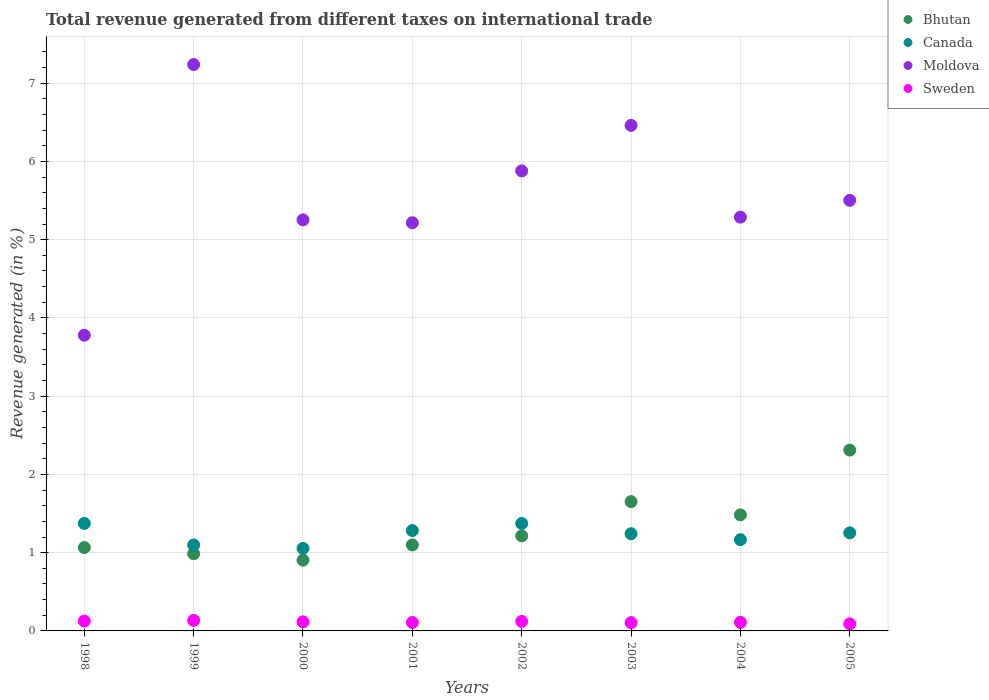How many different coloured dotlines are there?
Ensure brevity in your answer.  4. Is the number of dotlines equal to the number of legend labels?
Offer a terse response. Yes. What is the total revenue generated in Bhutan in 2002?
Your response must be concise. 1.21. Across all years, what is the maximum total revenue generated in Sweden?
Provide a short and direct response. 0.13. Across all years, what is the minimum total revenue generated in Canada?
Keep it short and to the point. 1.05. In which year was the total revenue generated in Moldova maximum?
Make the answer very short. 1999. What is the total total revenue generated in Bhutan in the graph?
Ensure brevity in your answer.  10.72. What is the difference between the total revenue generated in Moldova in 1998 and that in 2002?
Ensure brevity in your answer.  -2.1. What is the difference between the total revenue generated in Moldova in 1998 and the total revenue generated in Canada in 2004?
Ensure brevity in your answer.  2.61. What is the average total revenue generated in Bhutan per year?
Your answer should be very brief. 1.34. In the year 2002, what is the difference between the total revenue generated in Canada and total revenue generated in Sweden?
Offer a terse response. 1.25. In how many years, is the total revenue generated in Moldova greater than 6.8 %?
Your answer should be compact. 1. What is the ratio of the total revenue generated in Sweden in 1998 to that in 2002?
Provide a succinct answer. 1.03. Is the total revenue generated in Sweden in 1998 less than that in 2003?
Make the answer very short. No. What is the difference between the highest and the second highest total revenue generated in Canada?
Your answer should be very brief. 0. What is the difference between the highest and the lowest total revenue generated in Sweden?
Make the answer very short. 0.04. Is the sum of the total revenue generated in Sweden in 1999 and 2003 greater than the maximum total revenue generated in Bhutan across all years?
Offer a terse response. No. Is it the case that in every year, the sum of the total revenue generated in Bhutan and total revenue generated in Moldova  is greater than the total revenue generated in Canada?
Make the answer very short. Yes. Is the total revenue generated in Moldova strictly greater than the total revenue generated in Sweden over the years?
Your answer should be very brief. Yes. Is the total revenue generated in Bhutan strictly less than the total revenue generated in Sweden over the years?
Your response must be concise. No. How many dotlines are there?
Keep it short and to the point. 4. What is the difference between two consecutive major ticks on the Y-axis?
Provide a succinct answer. 1. Does the graph contain any zero values?
Give a very brief answer. No. What is the title of the graph?
Your answer should be compact. Total revenue generated from different taxes on international trade. Does "High income" appear as one of the legend labels in the graph?
Offer a very short reply. No. What is the label or title of the Y-axis?
Make the answer very short. Revenue generated (in %). What is the Revenue generated (in %) of Bhutan in 1998?
Give a very brief answer. 1.07. What is the Revenue generated (in %) of Canada in 1998?
Ensure brevity in your answer.  1.37. What is the Revenue generated (in %) of Moldova in 1998?
Ensure brevity in your answer.  3.78. What is the Revenue generated (in %) in Sweden in 1998?
Offer a terse response. 0.13. What is the Revenue generated (in %) of Bhutan in 1999?
Provide a succinct answer. 0.99. What is the Revenue generated (in %) in Canada in 1999?
Offer a very short reply. 1.1. What is the Revenue generated (in %) in Moldova in 1999?
Offer a terse response. 7.24. What is the Revenue generated (in %) in Sweden in 1999?
Offer a terse response. 0.13. What is the Revenue generated (in %) of Bhutan in 2000?
Your answer should be compact. 0.91. What is the Revenue generated (in %) of Canada in 2000?
Your response must be concise. 1.05. What is the Revenue generated (in %) of Moldova in 2000?
Provide a succinct answer. 5.25. What is the Revenue generated (in %) of Sweden in 2000?
Provide a short and direct response. 0.12. What is the Revenue generated (in %) in Bhutan in 2001?
Keep it short and to the point. 1.1. What is the Revenue generated (in %) of Canada in 2001?
Provide a succinct answer. 1.28. What is the Revenue generated (in %) in Moldova in 2001?
Provide a succinct answer. 5.22. What is the Revenue generated (in %) of Sweden in 2001?
Provide a succinct answer. 0.11. What is the Revenue generated (in %) in Bhutan in 2002?
Keep it short and to the point. 1.21. What is the Revenue generated (in %) of Canada in 2002?
Provide a short and direct response. 1.37. What is the Revenue generated (in %) in Moldova in 2002?
Your response must be concise. 5.88. What is the Revenue generated (in %) in Sweden in 2002?
Ensure brevity in your answer.  0.12. What is the Revenue generated (in %) of Bhutan in 2003?
Your answer should be very brief. 1.65. What is the Revenue generated (in %) of Canada in 2003?
Your response must be concise. 1.24. What is the Revenue generated (in %) of Moldova in 2003?
Your response must be concise. 6.46. What is the Revenue generated (in %) of Sweden in 2003?
Keep it short and to the point. 0.11. What is the Revenue generated (in %) in Bhutan in 2004?
Your response must be concise. 1.48. What is the Revenue generated (in %) of Canada in 2004?
Your answer should be very brief. 1.17. What is the Revenue generated (in %) in Moldova in 2004?
Your answer should be compact. 5.29. What is the Revenue generated (in %) in Sweden in 2004?
Make the answer very short. 0.11. What is the Revenue generated (in %) of Bhutan in 2005?
Provide a succinct answer. 2.31. What is the Revenue generated (in %) of Canada in 2005?
Offer a terse response. 1.25. What is the Revenue generated (in %) in Moldova in 2005?
Keep it short and to the point. 5.5. What is the Revenue generated (in %) in Sweden in 2005?
Make the answer very short. 0.09. Across all years, what is the maximum Revenue generated (in %) in Bhutan?
Make the answer very short. 2.31. Across all years, what is the maximum Revenue generated (in %) of Canada?
Your answer should be compact. 1.37. Across all years, what is the maximum Revenue generated (in %) in Moldova?
Make the answer very short. 7.24. Across all years, what is the maximum Revenue generated (in %) of Sweden?
Ensure brevity in your answer.  0.13. Across all years, what is the minimum Revenue generated (in %) of Bhutan?
Provide a short and direct response. 0.91. Across all years, what is the minimum Revenue generated (in %) in Canada?
Provide a short and direct response. 1.05. Across all years, what is the minimum Revenue generated (in %) of Moldova?
Give a very brief answer. 3.78. Across all years, what is the minimum Revenue generated (in %) of Sweden?
Your response must be concise. 0.09. What is the total Revenue generated (in %) of Bhutan in the graph?
Ensure brevity in your answer.  10.72. What is the total Revenue generated (in %) of Canada in the graph?
Your response must be concise. 9.84. What is the total Revenue generated (in %) in Moldova in the graph?
Your response must be concise. 44.62. What is the total Revenue generated (in %) in Sweden in the graph?
Provide a succinct answer. 0.91. What is the difference between the Revenue generated (in %) of Bhutan in 1998 and that in 1999?
Offer a terse response. 0.08. What is the difference between the Revenue generated (in %) of Canada in 1998 and that in 1999?
Your answer should be compact. 0.28. What is the difference between the Revenue generated (in %) of Moldova in 1998 and that in 1999?
Give a very brief answer. -3.46. What is the difference between the Revenue generated (in %) in Sweden in 1998 and that in 1999?
Your answer should be very brief. -0.01. What is the difference between the Revenue generated (in %) in Bhutan in 1998 and that in 2000?
Ensure brevity in your answer.  0.16. What is the difference between the Revenue generated (in %) in Canada in 1998 and that in 2000?
Provide a short and direct response. 0.32. What is the difference between the Revenue generated (in %) in Moldova in 1998 and that in 2000?
Provide a succinct answer. -1.47. What is the difference between the Revenue generated (in %) of Sweden in 1998 and that in 2000?
Make the answer very short. 0.01. What is the difference between the Revenue generated (in %) of Bhutan in 1998 and that in 2001?
Your answer should be compact. -0.03. What is the difference between the Revenue generated (in %) of Canada in 1998 and that in 2001?
Offer a terse response. 0.09. What is the difference between the Revenue generated (in %) in Moldova in 1998 and that in 2001?
Provide a short and direct response. -1.44. What is the difference between the Revenue generated (in %) of Sweden in 1998 and that in 2001?
Your answer should be very brief. 0.02. What is the difference between the Revenue generated (in %) in Bhutan in 1998 and that in 2002?
Your response must be concise. -0.15. What is the difference between the Revenue generated (in %) in Canada in 1998 and that in 2002?
Your response must be concise. 0. What is the difference between the Revenue generated (in %) in Moldova in 1998 and that in 2002?
Ensure brevity in your answer.  -2.1. What is the difference between the Revenue generated (in %) in Sweden in 1998 and that in 2002?
Ensure brevity in your answer.  0. What is the difference between the Revenue generated (in %) of Bhutan in 1998 and that in 2003?
Ensure brevity in your answer.  -0.59. What is the difference between the Revenue generated (in %) of Canada in 1998 and that in 2003?
Your answer should be very brief. 0.13. What is the difference between the Revenue generated (in %) in Moldova in 1998 and that in 2003?
Your answer should be compact. -2.68. What is the difference between the Revenue generated (in %) in Sweden in 1998 and that in 2003?
Ensure brevity in your answer.  0.02. What is the difference between the Revenue generated (in %) of Bhutan in 1998 and that in 2004?
Make the answer very short. -0.42. What is the difference between the Revenue generated (in %) in Canada in 1998 and that in 2004?
Keep it short and to the point. 0.21. What is the difference between the Revenue generated (in %) in Moldova in 1998 and that in 2004?
Provide a succinct answer. -1.51. What is the difference between the Revenue generated (in %) in Sweden in 1998 and that in 2004?
Offer a very short reply. 0.02. What is the difference between the Revenue generated (in %) in Bhutan in 1998 and that in 2005?
Provide a short and direct response. -1.25. What is the difference between the Revenue generated (in %) in Canada in 1998 and that in 2005?
Make the answer very short. 0.12. What is the difference between the Revenue generated (in %) of Moldova in 1998 and that in 2005?
Offer a terse response. -1.72. What is the difference between the Revenue generated (in %) of Sweden in 1998 and that in 2005?
Your response must be concise. 0.04. What is the difference between the Revenue generated (in %) of Bhutan in 1999 and that in 2000?
Offer a terse response. 0.08. What is the difference between the Revenue generated (in %) of Canada in 1999 and that in 2000?
Give a very brief answer. 0.04. What is the difference between the Revenue generated (in %) in Moldova in 1999 and that in 2000?
Offer a terse response. 1.98. What is the difference between the Revenue generated (in %) in Sweden in 1999 and that in 2000?
Offer a terse response. 0.02. What is the difference between the Revenue generated (in %) in Bhutan in 1999 and that in 2001?
Provide a succinct answer. -0.11. What is the difference between the Revenue generated (in %) in Canada in 1999 and that in 2001?
Your response must be concise. -0.18. What is the difference between the Revenue generated (in %) in Moldova in 1999 and that in 2001?
Give a very brief answer. 2.02. What is the difference between the Revenue generated (in %) in Sweden in 1999 and that in 2001?
Ensure brevity in your answer.  0.03. What is the difference between the Revenue generated (in %) in Bhutan in 1999 and that in 2002?
Keep it short and to the point. -0.23. What is the difference between the Revenue generated (in %) of Canada in 1999 and that in 2002?
Your answer should be compact. -0.27. What is the difference between the Revenue generated (in %) in Moldova in 1999 and that in 2002?
Offer a very short reply. 1.36. What is the difference between the Revenue generated (in %) of Sweden in 1999 and that in 2002?
Offer a terse response. 0.01. What is the difference between the Revenue generated (in %) of Bhutan in 1999 and that in 2003?
Offer a very short reply. -0.67. What is the difference between the Revenue generated (in %) of Canada in 1999 and that in 2003?
Make the answer very short. -0.14. What is the difference between the Revenue generated (in %) of Moldova in 1999 and that in 2003?
Your answer should be very brief. 0.78. What is the difference between the Revenue generated (in %) in Sweden in 1999 and that in 2003?
Offer a very short reply. 0.03. What is the difference between the Revenue generated (in %) of Bhutan in 1999 and that in 2004?
Offer a terse response. -0.5. What is the difference between the Revenue generated (in %) in Canada in 1999 and that in 2004?
Give a very brief answer. -0.07. What is the difference between the Revenue generated (in %) of Moldova in 1999 and that in 2004?
Your response must be concise. 1.95. What is the difference between the Revenue generated (in %) in Sweden in 1999 and that in 2004?
Your answer should be very brief. 0.02. What is the difference between the Revenue generated (in %) of Bhutan in 1999 and that in 2005?
Your response must be concise. -1.32. What is the difference between the Revenue generated (in %) of Canada in 1999 and that in 2005?
Provide a succinct answer. -0.15. What is the difference between the Revenue generated (in %) of Moldova in 1999 and that in 2005?
Your answer should be compact. 1.74. What is the difference between the Revenue generated (in %) of Sweden in 1999 and that in 2005?
Your response must be concise. 0.04. What is the difference between the Revenue generated (in %) in Bhutan in 2000 and that in 2001?
Your answer should be compact. -0.19. What is the difference between the Revenue generated (in %) in Canada in 2000 and that in 2001?
Your response must be concise. -0.23. What is the difference between the Revenue generated (in %) of Moldova in 2000 and that in 2001?
Your answer should be compact. 0.04. What is the difference between the Revenue generated (in %) in Sweden in 2000 and that in 2001?
Offer a very short reply. 0.01. What is the difference between the Revenue generated (in %) in Bhutan in 2000 and that in 2002?
Make the answer very short. -0.31. What is the difference between the Revenue generated (in %) in Canada in 2000 and that in 2002?
Provide a succinct answer. -0.32. What is the difference between the Revenue generated (in %) in Moldova in 2000 and that in 2002?
Your answer should be very brief. -0.63. What is the difference between the Revenue generated (in %) in Sweden in 2000 and that in 2002?
Ensure brevity in your answer.  -0.01. What is the difference between the Revenue generated (in %) of Bhutan in 2000 and that in 2003?
Give a very brief answer. -0.75. What is the difference between the Revenue generated (in %) in Canada in 2000 and that in 2003?
Make the answer very short. -0.19. What is the difference between the Revenue generated (in %) of Moldova in 2000 and that in 2003?
Provide a short and direct response. -1.21. What is the difference between the Revenue generated (in %) of Sweden in 2000 and that in 2003?
Make the answer very short. 0.01. What is the difference between the Revenue generated (in %) in Bhutan in 2000 and that in 2004?
Provide a short and direct response. -0.58. What is the difference between the Revenue generated (in %) in Canada in 2000 and that in 2004?
Ensure brevity in your answer.  -0.11. What is the difference between the Revenue generated (in %) in Moldova in 2000 and that in 2004?
Your answer should be very brief. -0.03. What is the difference between the Revenue generated (in %) of Sweden in 2000 and that in 2004?
Provide a succinct answer. 0.01. What is the difference between the Revenue generated (in %) of Bhutan in 2000 and that in 2005?
Provide a short and direct response. -1.41. What is the difference between the Revenue generated (in %) of Canada in 2000 and that in 2005?
Make the answer very short. -0.2. What is the difference between the Revenue generated (in %) of Moldova in 2000 and that in 2005?
Your answer should be compact. -0.25. What is the difference between the Revenue generated (in %) in Sweden in 2000 and that in 2005?
Keep it short and to the point. 0.03. What is the difference between the Revenue generated (in %) in Bhutan in 2001 and that in 2002?
Provide a succinct answer. -0.12. What is the difference between the Revenue generated (in %) in Canada in 2001 and that in 2002?
Your answer should be very brief. -0.09. What is the difference between the Revenue generated (in %) of Moldova in 2001 and that in 2002?
Your response must be concise. -0.66. What is the difference between the Revenue generated (in %) of Sweden in 2001 and that in 2002?
Ensure brevity in your answer.  -0.01. What is the difference between the Revenue generated (in %) of Bhutan in 2001 and that in 2003?
Keep it short and to the point. -0.55. What is the difference between the Revenue generated (in %) in Canada in 2001 and that in 2003?
Your answer should be compact. 0.04. What is the difference between the Revenue generated (in %) of Moldova in 2001 and that in 2003?
Your answer should be very brief. -1.24. What is the difference between the Revenue generated (in %) of Sweden in 2001 and that in 2003?
Keep it short and to the point. 0. What is the difference between the Revenue generated (in %) in Bhutan in 2001 and that in 2004?
Your answer should be compact. -0.38. What is the difference between the Revenue generated (in %) of Canada in 2001 and that in 2004?
Offer a very short reply. 0.12. What is the difference between the Revenue generated (in %) in Moldova in 2001 and that in 2004?
Your answer should be compact. -0.07. What is the difference between the Revenue generated (in %) of Sweden in 2001 and that in 2004?
Provide a short and direct response. -0. What is the difference between the Revenue generated (in %) of Bhutan in 2001 and that in 2005?
Provide a succinct answer. -1.21. What is the difference between the Revenue generated (in %) of Canada in 2001 and that in 2005?
Offer a terse response. 0.03. What is the difference between the Revenue generated (in %) in Moldova in 2001 and that in 2005?
Ensure brevity in your answer.  -0.29. What is the difference between the Revenue generated (in %) in Sweden in 2001 and that in 2005?
Make the answer very short. 0.02. What is the difference between the Revenue generated (in %) in Bhutan in 2002 and that in 2003?
Give a very brief answer. -0.44. What is the difference between the Revenue generated (in %) in Canada in 2002 and that in 2003?
Your response must be concise. 0.13. What is the difference between the Revenue generated (in %) in Moldova in 2002 and that in 2003?
Keep it short and to the point. -0.58. What is the difference between the Revenue generated (in %) in Sweden in 2002 and that in 2003?
Keep it short and to the point. 0.02. What is the difference between the Revenue generated (in %) of Bhutan in 2002 and that in 2004?
Your answer should be very brief. -0.27. What is the difference between the Revenue generated (in %) in Canada in 2002 and that in 2004?
Your answer should be very brief. 0.21. What is the difference between the Revenue generated (in %) in Moldova in 2002 and that in 2004?
Your response must be concise. 0.59. What is the difference between the Revenue generated (in %) in Sweden in 2002 and that in 2004?
Give a very brief answer. 0.01. What is the difference between the Revenue generated (in %) of Bhutan in 2002 and that in 2005?
Provide a short and direct response. -1.1. What is the difference between the Revenue generated (in %) of Canada in 2002 and that in 2005?
Keep it short and to the point. 0.12. What is the difference between the Revenue generated (in %) of Moldova in 2002 and that in 2005?
Your answer should be compact. 0.38. What is the difference between the Revenue generated (in %) in Sweden in 2002 and that in 2005?
Ensure brevity in your answer.  0.03. What is the difference between the Revenue generated (in %) in Bhutan in 2003 and that in 2004?
Provide a succinct answer. 0.17. What is the difference between the Revenue generated (in %) in Canada in 2003 and that in 2004?
Your response must be concise. 0.08. What is the difference between the Revenue generated (in %) in Moldova in 2003 and that in 2004?
Ensure brevity in your answer.  1.17. What is the difference between the Revenue generated (in %) in Sweden in 2003 and that in 2004?
Give a very brief answer. -0. What is the difference between the Revenue generated (in %) in Bhutan in 2003 and that in 2005?
Offer a very short reply. -0.66. What is the difference between the Revenue generated (in %) of Canada in 2003 and that in 2005?
Your answer should be very brief. -0.01. What is the difference between the Revenue generated (in %) in Moldova in 2003 and that in 2005?
Give a very brief answer. 0.96. What is the difference between the Revenue generated (in %) of Sweden in 2003 and that in 2005?
Offer a terse response. 0.02. What is the difference between the Revenue generated (in %) in Bhutan in 2004 and that in 2005?
Offer a very short reply. -0.83. What is the difference between the Revenue generated (in %) of Canada in 2004 and that in 2005?
Offer a terse response. -0.09. What is the difference between the Revenue generated (in %) in Moldova in 2004 and that in 2005?
Offer a very short reply. -0.21. What is the difference between the Revenue generated (in %) in Sweden in 2004 and that in 2005?
Keep it short and to the point. 0.02. What is the difference between the Revenue generated (in %) in Bhutan in 1998 and the Revenue generated (in %) in Canada in 1999?
Your answer should be very brief. -0.03. What is the difference between the Revenue generated (in %) in Bhutan in 1998 and the Revenue generated (in %) in Moldova in 1999?
Provide a short and direct response. -6.17. What is the difference between the Revenue generated (in %) in Canada in 1998 and the Revenue generated (in %) in Moldova in 1999?
Ensure brevity in your answer.  -5.86. What is the difference between the Revenue generated (in %) of Canada in 1998 and the Revenue generated (in %) of Sweden in 1999?
Offer a terse response. 1.24. What is the difference between the Revenue generated (in %) of Moldova in 1998 and the Revenue generated (in %) of Sweden in 1999?
Make the answer very short. 3.64. What is the difference between the Revenue generated (in %) in Bhutan in 1998 and the Revenue generated (in %) in Canada in 2000?
Your response must be concise. 0.01. What is the difference between the Revenue generated (in %) in Bhutan in 1998 and the Revenue generated (in %) in Moldova in 2000?
Give a very brief answer. -4.19. What is the difference between the Revenue generated (in %) of Bhutan in 1998 and the Revenue generated (in %) of Sweden in 2000?
Give a very brief answer. 0.95. What is the difference between the Revenue generated (in %) in Canada in 1998 and the Revenue generated (in %) in Moldova in 2000?
Give a very brief answer. -3.88. What is the difference between the Revenue generated (in %) in Canada in 1998 and the Revenue generated (in %) in Sweden in 2000?
Provide a short and direct response. 1.26. What is the difference between the Revenue generated (in %) of Moldova in 1998 and the Revenue generated (in %) of Sweden in 2000?
Provide a succinct answer. 3.66. What is the difference between the Revenue generated (in %) in Bhutan in 1998 and the Revenue generated (in %) in Canada in 2001?
Give a very brief answer. -0.22. What is the difference between the Revenue generated (in %) in Bhutan in 1998 and the Revenue generated (in %) in Moldova in 2001?
Provide a succinct answer. -4.15. What is the difference between the Revenue generated (in %) in Bhutan in 1998 and the Revenue generated (in %) in Sweden in 2001?
Offer a very short reply. 0.96. What is the difference between the Revenue generated (in %) of Canada in 1998 and the Revenue generated (in %) of Moldova in 2001?
Offer a terse response. -3.84. What is the difference between the Revenue generated (in %) of Canada in 1998 and the Revenue generated (in %) of Sweden in 2001?
Give a very brief answer. 1.27. What is the difference between the Revenue generated (in %) in Moldova in 1998 and the Revenue generated (in %) in Sweden in 2001?
Provide a short and direct response. 3.67. What is the difference between the Revenue generated (in %) in Bhutan in 1998 and the Revenue generated (in %) in Canada in 2002?
Your response must be concise. -0.31. What is the difference between the Revenue generated (in %) in Bhutan in 1998 and the Revenue generated (in %) in Moldova in 2002?
Provide a short and direct response. -4.81. What is the difference between the Revenue generated (in %) of Bhutan in 1998 and the Revenue generated (in %) of Sweden in 2002?
Ensure brevity in your answer.  0.94. What is the difference between the Revenue generated (in %) in Canada in 1998 and the Revenue generated (in %) in Moldova in 2002?
Make the answer very short. -4.5. What is the difference between the Revenue generated (in %) in Canada in 1998 and the Revenue generated (in %) in Sweden in 2002?
Offer a very short reply. 1.25. What is the difference between the Revenue generated (in %) in Moldova in 1998 and the Revenue generated (in %) in Sweden in 2002?
Offer a terse response. 3.66. What is the difference between the Revenue generated (in %) of Bhutan in 1998 and the Revenue generated (in %) of Canada in 2003?
Ensure brevity in your answer.  -0.18. What is the difference between the Revenue generated (in %) of Bhutan in 1998 and the Revenue generated (in %) of Moldova in 2003?
Your answer should be very brief. -5.4. What is the difference between the Revenue generated (in %) of Bhutan in 1998 and the Revenue generated (in %) of Sweden in 2003?
Your answer should be very brief. 0.96. What is the difference between the Revenue generated (in %) in Canada in 1998 and the Revenue generated (in %) in Moldova in 2003?
Give a very brief answer. -5.09. What is the difference between the Revenue generated (in %) of Canada in 1998 and the Revenue generated (in %) of Sweden in 2003?
Your answer should be very brief. 1.27. What is the difference between the Revenue generated (in %) in Moldova in 1998 and the Revenue generated (in %) in Sweden in 2003?
Your answer should be compact. 3.67. What is the difference between the Revenue generated (in %) of Bhutan in 1998 and the Revenue generated (in %) of Canada in 2004?
Offer a terse response. -0.1. What is the difference between the Revenue generated (in %) in Bhutan in 1998 and the Revenue generated (in %) in Moldova in 2004?
Give a very brief answer. -4.22. What is the difference between the Revenue generated (in %) in Bhutan in 1998 and the Revenue generated (in %) in Sweden in 2004?
Provide a short and direct response. 0.96. What is the difference between the Revenue generated (in %) in Canada in 1998 and the Revenue generated (in %) in Moldova in 2004?
Ensure brevity in your answer.  -3.91. What is the difference between the Revenue generated (in %) in Canada in 1998 and the Revenue generated (in %) in Sweden in 2004?
Provide a short and direct response. 1.26. What is the difference between the Revenue generated (in %) in Moldova in 1998 and the Revenue generated (in %) in Sweden in 2004?
Offer a very short reply. 3.67. What is the difference between the Revenue generated (in %) of Bhutan in 1998 and the Revenue generated (in %) of Canada in 2005?
Provide a succinct answer. -0.19. What is the difference between the Revenue generated (in %) in Bhutan in 1998 and the Revenue generated (in %) in Moldova in 2005?
Offer a very short reply. -4.44. What is the difference between the Revenue generated (in %) of Bhutan in 1998 and the Revenue generated (in %) of Sweden in 2005?
Give a very brief answer. 0.98. What is the difference between the Revenue generated (in %) of Canada in 1998 and the Revenue generated (in %) of Moldova in 2005?
Provide a succinct answer. -4.13. What is the difference between the Revenue generated (in %) of Canada in 1998 and the Revenue generated (in %) of Sweden in 2005?
Give a very brief answer. 1.28. What is the difference between the Revenue generated (in %) of Moldova in 1998 and the Revenue generated (in %) of Sweden in 2005?
Offer a terse response. 3.69. What is the difference between the Revenue generated (in %) of Bhutan in 1999 and the Revenue generated (in %) of Canada in 2000?
Offer a very short reply. -0.07. What is the difference between the Revenue generated (in %) in Bhutan in 1999 and the Revenue generated (in %) in Moldova in 2000?
Provide a short and direct response. -4.27. What is the difference between the Revenue generated (in %) of Bhutan in 1999 and the Revenue generated (in %) of Sweden in 2000?
Offer a very short reply. 0.87. What is the difference between the Revenue generated (in %) in Canada in 1999 and the Revenue generated (in %) in Moldova in 2000?
Give a very brief answer. -4.15. What is the difference between the Revenue generated (in %) in Canada in 1999 and the Revenue generated (in %) in Sweden in 2000?
Your answer should be very brief. 0.98. What is the difference between the Revenue generated (in %) of Moldova in 1999 and the Revenue generated (in %) of Sweden in 2000?
Keep it short and to the point. 7.12. What is the difference between the Revenue generated (in %) in Bhutan in 1999 and the Revenue generated (in %) in Canada in 2001?
Offer a terse response. -0.3. What is the difference between the Revenue generated (in %) of Bhutan in 1999 and the Revenue generated (in %) of Moldova in 2001?
Provide a short and direct response. -4.23. What is the difference between the Revenue generated (in %) in Bhutan in 1999 and the Revenue generated (in %) in Sweden in 2001?
Offer a terse response. 0.88. What is the difference between the Revenue generated (in %) of Canada in 1999 and the Revenue generated (in %) of Moldova in 2001?
Offer a terse response. -4.12. What is the difference between the Revenue generated (in %) in Canada in 1999 and the Revenue generated (in %) in Sweden in 2001?
Make the answer very short. 0.99. What is the difference between the Revenue generated (in %) of Moldova in 1999 and the Revenue generated (in %) of Sweden in 2001?
Your answer should be compact. 7.13. What is the difference between the Revenue generated (in %) in Bhutan in 1999 and the Revenue generated (in %) in Canada in 2002?
Provide a short and direct response. -0.39. What is the difference between the Revenue generated (in %) of Bhutan in 1999 and the Revenue generated (in %) of Moldova in 2002?
Your response must be concise. -4.89. What is the difference between the Revenue generated (in %) in Bhutan in 1999 and the Revenue generated (in %) in Sweden in 2002?
Offer a terse response. 0.86. What is the difference between the Revenue generated (in %) in Canada in 1999 and the Revenue generated (in %) in Moldova in 2002?
Your answer should be very brief. -4.78. What is the difference between the Revenue generated (in %) of Canada in 1999 and the Revenue generated (in %) of Sweden in 2002?
Your response must be concise. 0.98. What is the difference between the Revenue generated (in %) in Moldova in 1999 and the Revenue generated (in %) in Sweden in 2002?
Ensure brevity in your answer.  7.12. What is the difference between the Revenue generated (in %) of Bhutan in 1999 and the Revenue generated (in %) of Canada in 2003?
Ensure brevity in your answer.  -0.26. What is the difference between the Revenue generated (in %) of Bhutan in 1999 and the Revenue generated (in %) of Moldova in 2003?
Your response must be concise. -5.47. What is the difference between the Revenue generated (in %) in Bhutan in 1999 and the Revenue generated (in %) in Sweden in 2003?
Offer a terse response. 0.88. What is the difference between the Revenue generated (in %) of Canada in 1999 and the Revenue generated (in %) of Moldova in 2003?
Your answer should be compact. -5.36. What is the difference between the Revenue generated (in %) of Moldova in 1999 and the Revenue generated (in %) of Sweden in 2003?
Offer a very short reply. 7.13. What is the difference between the Revenue generated (in %) in Bhutan in 1999 and the Revenue generated (in %) in Canada in 2004?
Your answer should be compact. -0.18. What is the difference between the Revenue generated (in %) of Bhutan in 1999 and the Revenue generated (in %) of Moldova in 2004?
Provide a short and direct response. -4.3. What is the difference between the Revenue generated (in %) in Bhutan in 1999 and the Revenue generated (in %) in Sweden in 2004?
Provide a short and direct response. 0.88. What is the difference between the Revenue generated (in %) of Canada in 1999 and the Revenue generated (in %) of Moldova in 2004?
Give a very brief answer. -4.19. What is the difference between the Revenue generated (in %) of Moldova in 1999 and the Revenue generated (in %) of Sweden in 2004?
Your response must be concise. 7.13. What is the difference between the Revenue generated (in %) in Bhutan in 1999 and the Revenue generated (in %) in Canada in 2005?
Your response must be concise. -0.27. What is the difference between the Revenue generated (in %) in Bhutan in 1999 and the Revenue generated (in %) in Moldova in 2005?
Provide a succinct answer. -4.52. What is the difference between the Revenue generated (in %) in Bhutan in 1999 and the Revenue generated (in %) in Sweden in 2005?
Keep it short and to the point. 0.9. What is the difference between the Revenue generated (in %) in Canada in 1999 and the Revenue generated (in %) in Moldova in 2005?
Your answer should be very brief. -4.4. What is the difference between the Revenue generated (in %) of Canada in 1999 and the Revenue generated (in %) of Sweden in 2005?
Make the answer very short. 1.01. What is the difference between the Revenue generated (in %) of Moldova in 1999 and the Revenue generated (in %) of Sweden in 2005?
Your answer should be very brief. 7.15. What is the difference between the Revenue generated (in %) of Bhutan in 2000 and the Revenue generated (in %) of Canada in 2001?
Provide a short and direct response. -0.38. What is the difference between the Revenue generated (in %) of Bhutan in 2000 and the Revenue generated (in %) of Moldova in 2001?
Your answer should be compact. -4.31. What is the difference between the Revenue generated (in %) in Bhutan in 2000 and the Revenue generated (in %) in Sweden in 2001?
Ensure brevity in your answer.  0.8. What is the difference between the Revenue generated (in %) of Canada in 2000 and the Revenue generated (in %) of Moldova in 2001?
Keep it short and to the point. -4.16. What is the difference between the Revenue generated (in %) of Canada in 2000 and the Revenue generated (in %) of Sweden in 2001?
Your response must be concise. 0.95. What is the difference between the Revenue generated (in %) of Moldova in 2000 and the Revenue generated (in %) of Sweden in 2001?
Your answer should be compact. 5.15. What is the difference between the Revenue generated (in %) in Bhutan in 2000 and the Revenue generated (in %) in Canada in 2002?
Your answer should be very brief. -0.47. What is the difference between the Revenue generated (in %) in Bhutan in 2000 and the Revenue generated (in %) in Moldova in 2002?
Ensure brevity in your answer.  -4.97. What is the difference between the Revenue generated (in %) in Bhutan in 2000 and the Revenue generated (in %) in Sweden in 2002?
Make the answer very short. 0.78. What is the difference between the Revenue generated (in %) of Canada in 2000 and the Revenue generated (in %) of Moldova in 2002?
Offer a terse response. -4.82. What is the difference between the Revenue generated (in %) in Canada in 2000 and the Revenue generated (in %) in Sweden in 2002?
Your answer should be very brief. 0.93. What is the difference between the Revenue generated (in %) of Moldova in 2000 and the Revenue generated (in %) of Sweden in 2002?
Ensure brevity in your answer.  5.13. What is the difference between the Revenue generated (in %) in Bhutan in 2000 and the Revenue generated (in %) in Canada in 2003?
Ensure brevity in your answer.  -0.34. What is the difference between the Revenue generated (in %) of Bhutan in 2000 and the Revenue generated (in %) of Moldova in 2003?
Keep it short and to the point. -5.56. What is the difference between the Revenue generated (in %) of Bhutan in 2000 and the Revenue generated (in %) of Sweden in 2003?
Offer a very short reply. 0.8. What is the difference between the Revenue generated (in %) of Canada in 2000 and the Revenue generated (in %) of Moldova in 2003?
Provide a succinct answer. -5.41. What is the difference between the Revenue generated (in %) of Canada in 2000 and the Revenue generated (in %) of Sweden in 2003?
Ensure brevity in your answer.  0.95. What is the difference between the Revenue generated (in %) of Moldova in 2000 and the Revenue generated (in %) of Sweden in 2003?
Ensure brevity in your answer.  5.15. What is the difference between the Revenue generated (in %) of Bhutan in 2000 and the Revenue generated (in %) of Canada in 2004?
Keep it short and to the point. -0.26. What is the difference between the Revenue generated (in %) in Bhutan in 2000 and the Revenue generated (in %) in Moldova in 2004?
Your answer should be compact. -4.38. What is the difference between the Revenue generated (in %) in Bhutan in 2000 and the Revenue generated (in %) in Sweden in 2004?
Keep it short and to the point. 0.8. What is the difference between the Revenue generated (in %) of Canada in 2000 and the Revenue generated (in %) of Moldova in 2004?
Give a very brief answer. -4.23. What is the difference between the Revenue generated (in %) in Canada in 2000 and the Revenue generated (in %) in Sweden in 2004?
Your response must be concise. 0.94. What is the difference between the Revenue generated (in %) in Moldova in 2000 and the Revenue generated (in %) in Sweden in 2004?
Ensure brevity in your answer.  5.14. What is the difference between the Revenue generated (in %) in Bhutan in 2000 and the Revenue generated (in %) in Canada in 2005?
Offer a terse response. -0.35. What is the difference between the Revenue generated (in %) of Bhutan in 2000 and the Revenue generated (in %) of Moldova in 2005?
Provide a short and direct response. -4.6. What is the difference between the Revenue generated (in %) of Bhutan in 2000 and the Revenue generated (in %) of Sweden in 2005?
Offer a terse response. 0.82. What is the difference between the Revenue generated (in %) in Canada in 2000 and the Revenue generated (in %) in Moldova in 2005?
Give a very brief answer. -4.45. What is the difference between the Revenue generated (in %) in Canada in 2000 and the Revenue generated (in %) in Sweden in 2005?
Ensure brevity in your answer.  0.96. What is the difference between the Revenue generated (in %) of Moldova in 2000 and the Revenue generated (in %) of Sweden in 2005?
Offer a very short reply. 5.16. What is the difference between the Revenue generated (in %) of Bhutan in 2001 and the Revenue generated (in %) of Canada in 2002?
Ensure brevity in your answer.  -0.27. What is the difference between the Revenue generated (in %) in Bhutan in 2001 and the Revenue generated (in %) in Moldova in 2002?
Give a very brief answer. -4.78. What is the difference between the Revenue generated (in %) in Bhutan in 2001 and the Revenue generated (in %) in Sweden in 2002?
Keep it short and to the point. 0.98. What is the difference between the Revenue generated (in %) of Canada in 2001 and the Revenue generated (in %) of Moldova in 2002?
Offer a terse response. -4.6. What is the difference between the Revenue generated (in %) in Canada in 2001 and the Revenue generated (in %) in Sweden in 2002?
Make the answer very short. 1.16. What is the difference between the Revenue generated (in %) in Moldova in 2001 and the Revenue generated (in %) in Sweden in 2002?
Your answer should be compact. 5.09. What is the difference between the Revenue generated (in %) of Bhutan in 2001 and the Revenue generated (in %) of Canada in 2003?
Give a very brief answer. -0.14. What is the difference between the Revenue generated (in %) in Bhutan in 2001 and the Revenue generated (in %) in Moldova in 2003?
Your answer should be compact. -5.36. What is the difference between the Revenue generated (in %) of Canada in 2001 and the Revenue generated (in %) of Moldova in 2003?
Provide a short and direct response. -5.18. What is the difference between the Revenue generated (in %) of Canada in 2001 and the Revenue generated (in %) of Sweden in 2003?
Provide a succinct answer. 1.18. What is the difference between the Revenue generated (in %) in Moldova in 2001 and the Revenue generated (in %) in Sweden in 2003?
Offer a very short reply. 5.11. What is the difference between the Revenue generated (in %) in Bhutan in 2001 and the Revenue generated (in %) in Canada in 2004?
Offer a terse response. -0.07. What is the difference between the Revenue generated (in %) in Bhutan in 2001 and the Revenue generated (in %) in Moldova in 2004?
Offer a terse response. -4.19. What is the difference between the Revenue generated (in %) of Canada in 2001 and the Revenue generated (in %) of Moldova in 2004?
Offer a terse response. -4.01. What is the difference between the Revenue generated (in %) of Canada in 2001 and the Revenue generated (in %) of Sweden in 2004?
Keep it short and to the point. 1.17. What is the difference between the Revenue generated (in %) in Moldova in 2001 and the Revenue generated (in %) in Sweden in 2004?
Give a very brief answer. 5.11. What is the difference between the Revenue generated (in %) of Bhutan in 2001 and the Revenue generated (in %) of Canada in 2005?
Your answer should be compact. -0.15. What is the difference between the Revenue generated (in %) of Bhutan in 2001 and the Revenue generated (in %) of Moldova in 2005?
Provide a succinct answer. -4.4. What is the difference between the Revenue generated (in %) of Bhutan in 2001 and the Revenue generated (in %) of Sweden in 2005?
Give a very brief answer. 1.01. What is the difference between the Revenue generated (in %) in Canada in 2001 and the Revenue generated (in %) in Moldova in 2005?
Give a very brief answer. -4.22. What is the difference between the Revenue generated (in %) of Canada in 2001 and the Revenue generated (in %) of Sweden in 2005?
Provide a short and direct response. 1.19. What is the difference between the Revenue generated (in %) in Moldova in 2001 and the Revenue generated (in %) in Sweden in 2005?
Provide a succinct answer. 5.13. What is the difference between the Revenue generated (in %) of Bhutan in 2002 and the Revenue generated (in %) of Canada in 2003?
Provide a succinct answer. -0.03. What is the difference between the Revenue generated (in %) in Bhutan in 2002 and the Revenue generated (in %) in Moldova in 2003?
Offer a terse response. -5.25. What is the difference between the Revenue generated (in %) of Bhutan in 2002 and the Revenue generated (in %) of Sweden in 2003?
Your response must be concise. 1.11. What is the difference between the Revenue generated (in %) in Canada in 2002 and the Revenue generated (in %) in Moldova in 2003?
Keep it short and to the point. -5.09. What is the difference between the Revenue generated (in %) of Canada in 2002 and the Revenue generated (in %) of Sweden in 2003?
Your response must be concise. 1.27. What is the difference between the Revenue generated (in %) in Moldova in 2002 and the Revenue generated (in %) in Sweden in 2003?
Make the answer very short. 5.77. What is the difference between the Revenue generated (in %) in Bhutan in 2002 and the Revenue generated (in %) in Canada in 2004?
Your answer should be very brief. 0.05. What is the difference between the Revenue generated (in %) of Bhutan in 2002 and the Revenue generated (in %) of Moldova in 2004?
Make the answer very short. -4.07. What is the difference between the Revenue generated (in %) of Bhutan in 2002 and the Revenue generated (in %) of Sweden in 2004?
Your answer should be very brief. 1.11. What is the difference between the Revenue generated (in %) of Canada in 2002 and the Revenue generated (in %) of Moldova in 2004?
Keep it short and to the point. -3.91. What is the difference between the Revenue generated (in %) of Canada in 2002 and the Revenue generated (in %) of Sweden in 2004?
Ensure brevity in your answer.  1.26. What is the difference between the Revenue generated (in %) of Moldova in 2002 and the Revenue generated (in %) of Sweden in 2004?
Provide a succinct answer. 5.77. What is the difference between the Revenue generated (in %) of Bhutan in 2002 and the Revenue generated (in %) of Canada in 2005?
Offer a terse response. -0.04. What is the difference between the Revenue generated (in %) in Bhutan in 2002 and the Revenue generated (in %) in Moldova in 2005?
Provide a succinct answer. -4.29. What is the difference between the Revenue generated (in %) in Bhutan in 2002 and the Revenue generated (in %) in Sweden in 2005?
Offer a terse response. 1.12. What is the difference between the Revenue generated (in %) in Canada in 2002 and the Revenue generated (in %) in Moldova in 2005?
Offer a terse response. -4.13. What is the difference between the Revenue generated (in %) of Canada in 2002 and the Revenue generated (in %) of Sweden in 2005?
Your answer should be very brief. 1.28. What is the difference between the Revenue generated (in %) in Moldova in 2002 and the Revenue generated (in %) in Sweden in 2005?
Offer a very short reply. 5.79. What is the difference between the Revenue generated (in %) of Bhutan in 2003 and the Revenue generated (in %) of Canada in 2004?
Ensure brevity in your answer.  0.49. What is the difference between the Revenue generated (in %) in Bhutan in 2003 and the Revenue generated (in %) in Moldova in 2004?
Give a very brief answer. -3.64. What is the difference between the Revenue generated (in %) of Bhutan in 2003 and the Revenue generated (in %) of Sweden in 2004?
Make the answer very short. 1.54. What is the difference between the Revenue generated (in %) in Canada in 2003 and the Revenue generated (in %) in Moldova in 2004?
Ensure brevity in your answer.  -4.05. What is the difference between the Revenue generated (in %) of Canada in 2003 and the Revenue generated (in %) of Sweden in 2004?
Ensure brevity in your answer.  1.13. What is the difference between the Revenue generated (in %) of Moldova in 2003 and the Revenue generated (in %) of Sweden in 2004?
Your response must be concise. 6.35. What is the difference between the Revenue generated (in %) of Bhutan in 2003 and the Revenue generated (in %) of Canada in 2005?
Make the answer very short. 0.4. What is the difference between the Revenue generated (in %) of Bhutan in 2003 and the Revenue generated (in %) of Moldova in 2005?
Offer a very short reply. -3.85. What is the difference between the Revenue generated (in %) of Bhutan in 2003 and the Revenue generated (in %) of Sweden in 2005?
Offer a very short reply. 1.56. What is the difference between the Revenue generated (in %) of Canada in 2003 and the Revenue generated (in %) of Moldova in 2005?
Your answer should be very brief. -4.26. What is the difference between the Revenue generated (in %) of Canada in 2003 and the Revenue generated (in %) of Sweden in 2005?
Ensure brevity in your answer.  1.15. What is the difference between the Revenue generated (in %) in Moldova in 2003 and the Revenue generated (in %) in Sweden in 2005?
Make the answer very short. 6.37. What is the difference between the Revenue generated (in %) in Bhutan in 2004 and the Revenue generated (in %) in Canada in 2005?
Make the answer very short. 0.23. What is the difference between the Revenue generated (in %) of Bhutan in 2004 and the Revenue generated (in %) of Moldova in 2005?
Give a very brief answer. -4.02. What is the difference between the Revenue generated (in %) in Bhutan in 2004 and the Revenue generated (in %) in Sweden in 2005?
Offer a terse response. 1.39. What is the difference between the Revenue generated (in %) in Canada in 2004 and the Revenue generated (in %) in Moldova in 2005?
Ensure brevity in your answer.  -4.34. What is the difference between the Revenue generated (in %) in Canada in 2004 and the Revenue generated (in %) in Sweden in 2005?
Offer a terse response. 1.08. What is the difference between the Revenue generated (in %) of Moldova in 2004 and the Revenue generated (in %) of Sweden in 2005?
Provide a succinct answer. 5.2. What is the average Revenue generated (in %) in Bhutan per year?
Keep it short and to the point. 1.34. What is the average Revenue generated (in %) in Canada per year?
Provide a short and direct response. 1.23. What is the average Revenue generated (in %) of Moldova per year?
Make the answer very short. 5.58. What is the average Revenue generated (in %) of Sweden per year?
Provide a short and direct response. 0.11. In the year 1998, what is the difference between the Revenue generated (in %) in Bhutan and Revenue generated (in %) in Canada?
Ensure brevity in your answer.  -0.31. In the year 1998, what is the difference between the Revenue generated (in %) in Bhutan and Revenue generated (in %) in Moldova?
Your response must be concise. -2.71. In the year 1998, what is the difference between the Revenue generated (in %) of Bhutan and Revenue generated (in %) of Sweden?
Offer a terse response. 0.94. In the year 1998, what is the difference between the Revenue generated (in %) of Canada and Revenue generated (in %) of Moldova?
Provide a succinct answer. -2.4. In the year 1998, what is the difference between the Revenue generated (in %) of Canada and Revenue generated (in %) of Sweden?
Make the answer very short. 1.25. In the year 1998, what is the difference between the Revenue generated (in %) of Moldova and Revenue generated (in %) of Sweden?
Keep it short and to the point. 3.65. In the year 1999, what is the difference between the Revenue generated (in %) in Bhutan and Revenue generated (in %) in Canada?
Provide a succinct answer. -0.11. In the year 1999, what is the difference between the Revenue generated (in %) of Bhutan and Revenue generated (in %) of Moldova?
Make the answer very short. -6.25. In the year 1999, what is the difference between the Revenue generated (in %) of Bhutan and Revenue generated (in %) of Sweden?
Keep it short and to the point. 0.85. In the year 1999, what is the difference between the Revenue generated (in %) in Canada and Revenue generated (in %) in Moldova?
Ensure brevity in your answer.  -6.14. In the year 1999, what is the difference between the Revenue generated (in %) of Canada and Revenue generated (in %) of Sweden?
Provide a short and direct response. 0.96. In the year 1999, what is the difference between the Revenue generated (in %) of Moldova and Revenue generated (in %) of Sweden?
Make the answer very short. 7.1. In the year 2000, what is the difference between the Revenue generated (in %) in Bhutan and Revenue generated (in %) in Canada?
Offer a very short reply. -0.15. In the year 2000, what is the difference between the Revenue generated (in %) of Bhutan and Revenue generated (in %) of Moldova?
Your answer should be compact. -4.35. In the year 2000, what is the difference between the Revenue generated (in %) in Bhutan and Revenue generated (in %) in Sweden?
Make the answer very short. 0.79. In the year 2000, what is the difference between the Revenue generated (in %) in Canada and Revenue generated (in %) in Moldova?
Make the answer very short. -4.2. In the year 2000, what is the difference between the Revenue generated (in %) of Canada and Revenue generated (in %) of Sweden?
Keep it short and to the point. 0.94. In the year 2000, what is the difference between the Revenue generated (in %) of Moldova and Revenue generated (in %) of Sweden?
Your response must be concise. 5.14. In the year 2001, what is the difference between the Revenue generated (in %) of Bhutan and Revenue generated (in %) of Canada?
Your answer should be compact. -0.18. In the year 2001, what is the difference between the Revenue generated (in %) in Bhutan and Revenue generated (in %) in Moldova?
Provide a short and direct response. -4.12. In the year 2001, what is the difference between the Revenue generated (in %) in Bhutan and Revenue generated (in %) in Sweden?
Keep it short and to the point. 0.99. In the year 2001, what is the difference between the Revenue generated (in %) in Canada and Revenue generated (in %) in Moldova?
Give a very brief answer. -3.93. In the year 2001, what is the difference between the Revenue generated (in %) in Canada and Revenue generated (in %) in Sweden?
Ensure brevity in your answer.  1.17. In the year 2001, what is the difference between the Revenue generated (in %) of Moldova and Revenue generated (in %) of Sweden?
Offer a terse response. 5.11. In the year 2002, what is the difference between the Revenue generated (in %) of Bhutan and Revenue generated (in %) of Canada?
Your answer should be very brief. -0.16. In the year 2002, what is the difference between the Revenue generated (in %) of Bhutan and Revenue generated (in %) of Moldova?
Your answer should be compact. -4.66. In the year 2002, what is the difference between the Revenue generated (in %) in Bhutan and Revenue generated (in %) in Sweden?
Your answer should be compact. 1.09. In the year 2002, what is the difference between the Revenue generated (in %) in Canada and Revenue generated (in %) in Moldova?
Ensure brevity in your answer.  -4.51. In the year 2002, what is the difference between the Revenue generated (in %) of Canada and Revenue generated (in %) of Sweden?
Ensure brevity in your answer.  1.25. In the year 2002, what is the difference between the Revenue generated (in %) in Moldova and Revenue generated (in %) in Sweden?
Your response must be concise. 5.76. In the year 2003, what is the difference between the Revenue generated (in %) of Bhutan and Revenue generated (in %) of Canada?
Your response must be concise. 0.41. In the year 2003, what is the difference between the Revenue generated (in %) in Bhutan and Revenue generated (in %) in Moldova?
Your response must be concise. -4.81. In the year 2003, what is the difference between the Revenue generated (in %) in Bhutan and Revenue generated (in %) in Sweden?
Ensure brevity in your answer.  1.55. In the year 2003, what is the difference between the Revenue generated (in %) of Canada and Revenue generated (in %) of Moldova?
Ensure brevity in your answer.  -5.22. In the year 2003, what is the difference between the Revenue generated (in %) of Canada and Revenue generated (in %) of Sweden?
Your response must be concise. 1.14. In the year 2003, what is the difference between the Revenue generated (in %) of Moldova and Revenue generated (in %) of Sweden?
Provide a short and direct response. 6.36. In the year 2004, what is the difference between the Revenue generated (in %) of Bhutan and Revenue generated (in %) of Canada?
Make the answer very short. 0.32. In the year 2004, what is the difference between the Revenue generated (in %) in Bhutan and Revenue generated (in %) in Moldova?
Give a very brief answer. -3.81. In the year 2004, what is the difference between the Revenue generated (in %) of Bhutan and Revenue generated (in %) of Sweden?
Your answer should be very brief. 1.37. In the year 2004, what is the difference between the Revenue generated (in %) of Canada and Revenue generated (in %) of Moldova?
Offer a terse response. -4.12. In the year 2004, what is the difference between the Revenue generated (in %) in Canada and Revenue generated (in %) in Sweden?
Ensure brevity in your answer.  1.06. In the year 2004, what is the difference between the Revenue generated (in %) of Moldova and Revenue generated (in %) of Sweden?
Your response must be concise. 5.18. In the year 2005, what is the difference between the Revenue generated (in %) in Bhutan and Revenue generated (in %) in Canada?
Keep it short and to the point. 1.06. In the year 2005, what is the difference between the Revenue generated (in %) of Bhutan and Revenue generated (in %) of Moldova?
Your answer should be very brief. -3.19. In the year 2005, what is the difference between the Revenue generated (in %) of Bhutan and Revenue generated (in %) of Sweden?
Offer a very short reply. 2.22. In the year 2005, what is the difference between the Revenue generated (in %) of Canada and Revenue generated (in %) of Moldova?
Keep it short and to the point. -4.25. In the year 2005, what is the difference between the Revenue generated (in %) in Canada and Revenue generated (in %) in Sweden?
Offer a very short reply. 1.16. In the year 2005, what is the difference between the Revenue generated (in %) of Moldova and Revenue generated (in %) of Sweden?
Make the answer very short. 5.41. What is the ratio of the Revenue generated (in %) of Bhutan in 1998 to that in 1999?
Provide a short and direct response. 1.08. What is the ratio of the Revenue generated (in %) of Canada in 1998 to that in 1999?
Provide a succinct answer. 1.25. What is the ratio of the Revenue generated (in %) of Moldova in 1998 to that in 1999?
Offer a terse response. 0.52. What is the ratio of the Revenue generated (in %) in Sweden in 1998 to that in 1999?
Ensure brevity in your answer.  0.94. What is the ratio of the Revenue generated (in %) in Bhutan in 1998 to that in 2000?
Your answer should be very brief. 1.18. What is the ratio of the Revenue generated (in %) in Canada in 1998 to that in 2000?
Provide a succinct answer. 1.3. What is the ratio of the Revenue generated (in %) of Moldova in 1998 to that in 2000?
Offer a very short reply. 0.72. What is the ratio of the Revenue generated (in %) of Sweden in 1998 to that in 2000?
Provide a succinct answer. 1.08. What is the ratio of the Revenue generated (in %) of Bhutan in 1998 to that in 2001?
Give a very brief answer. 0.97. What is the ratio of the Revenue generated (in %) of Canada in 1998 to that in 2001?
Your answer should be compact. 1.07. What is the ratio of the Revenue generated (in %) of Moldova in 1998 to that in 2001?
Make the answer very short. 0.72. What is the ratio of the Revenue generated (in %) of Sweden in 1998 to that in 2001?
Give a very brief answer. 1.16. What is the ratio of the Revenue generated (in %) in Bhutan in 1998 to that in 2002?
Keep it short and to the point. 0.88. What is the ratio of the Revenue generated (in %) in Moldova in 1998 to that in 2002?
Offer a terse response. 0.64. What is the ratio of the Revenue generated (in %) in Sweden in 1998 to that in 2002?
Offer a terse response. 1.03. What is the ratio of the Revenue generated (in %) of Bhutan in 1998 to that in 2003?
Make the answer very short. 0.64. What is the ratio of the Revenue generated (in %) of Canada in 1998 to that in 2003?
Offer a terse response. 1.11. What is the ratio of the Revenue generated (in %) of Moldova in 1998 to that in 2003?
Keep it short and to the point. 0.58. What is the ratio of the Revenue generated (in %) of Sweden in 1998 to that in 2003?
Ensure brevity in your answer.  1.19. What is the ratio of the Revenue generated (in %) of Bhutan in 1998 to that in 2004?
Your answer should be compact. 0.72. What is the ratio of the Revenue generated (in %) of Canada in 1998 to that in 2004?
Provide a short and direct response. 1.18. What is the ratio of the Revenue generated (in %) in Moldova in 1998 to that in 2004?
Your response must be concise. 0.71. What is the ratio of the Revenue generated (in %) in Sweden in 1998 to that in 2004?
Make the answer very short. 1.15. What is the ratio of the Revenue generated (in %) in Bhutan in 1998 to that in 2005?
Give a very brief answer. 0.46. What is the ratio of the Revenue generated (in %) of Canada in 1998 to that in 2005?
Make the answer very short. 1.1. What is the ratio of the Revenue generated (in %) of Moldova in 1998 to that in 2005?
Your answer should be compact. 0.69. What is the ratio of the Revenue generated (in %) in Sweden in 1998 to that in 2005?
Provide a succinct answer. 1.4. What is the ratio of the Revenue generated (in %) in Bhutan in 1999 to that in 2000?
Make the answer very short. 1.09. What is the ratio of the Revenue generated (in %) in Canada in 1999 to that in 2000?
Keep it short and to the point. 1.04. What is the ratio of the Revenue generated (in %) in Moldova in 1999 to that in 2000?
Keep it short and to the point. 1.38. What is the ratio of the Revenue generated (in %) of Sweden in 1999 to that in 2000?
Give a very brief answer. 1.16. What is the ratio of the Revenue generated (in %) in Bhutan in 1999 to that in 2001?
Your answer should be very brief. 0.9. What is the ratio of the Revenue generated (in %) of Canada in 1999 to that in 2001?
Offer a very short reply. 0.86. What is the ratio of the Revenue generated (in %) in Moldova in 1999 to that in 2001?
Offer a very short reply. 1.39. What is the ratio of the Revenue generated (in %) in Sweden in 1999 to that in 2001?
Your answer should be very brief. 1.24. What is the ratio of the Revenue generated (in %) of Bhutan in 1999 to that in 2002?
Give a very brief answer. 0.81. What is the ratio of the Revenue generated (in %) of Canada in 1999 to that in 2002?
Your answer should be compact. 0.8. What is the ratio of the Revenue generated (in %) in Moldova in 1999 to that in 2002?
Keep it short and to the point. 1.23. What is the ratio of the Revenue generated (in %) of Sweden in 1999 to that in 2002?
Make the answer very short. 1.1. What is the ratio of the Revenue generated (in %) in Bhutan in 1999 to that in 2003?
Your answer should be very brief. 0.6. What is the ratio of the Revenue generated (in %) of Canada in 1999 to that in 2003?
Offer a terse response. 0.88. What is the ratio of the Revenue generated (in %) in Moldova in 1999 to that in 2003?
Provide a short and direct response. 1.12. What is the ratio of the Revenue generated (in %) in Sweden in 1999 to that in 2003?
Your answer should be compact. 1.27. What is the ratio of the Revenue generated (in %) of Bhutan in 1999 to that in 2004?
Ensure brevity in your answer.  0.67. What is the ratio of the Revenue generated (in %) in Canada in 1999 to that in 2004?
Offer a terse response. 0.94. What is the ratio of the Revenue generated (in %) in Moldova in 1999 to that in 2004?
Make the answer very short. 1.37. What is the ratio of the Revenue generated (in %) of Sweden in 1999 to that in 2004?
Offer a very short reply. 1.23. What is the ratio of the Revenue generated (in %) in Bhutan in 1999 to that in 2005?
Your response must be concise. 0.43. What is the ratio of the Revenue generated (in %) of Canada in 1999 to that in 2005?
Offer a terse response. 0.88. What is the ratio of the Revenue generated (in %) in Moldova in 1999 to that in 2005?
Keep it short and to the point. 1.32. What is the ratio of the Revenue generated (in %) of Sweden in 1999 to that in 2005?
Offer a very short reply. 1.49. What is the ratio of the Revenue generated (in %) of Bhutan in 2000 to that in 2001?
Ensure brevity in your answer.  0.82. What is the ratio of the Revenue generated (in %) in Canada in 2000 to that in 2001?
Keep it short and to the point. 0.82. What is the ratio of the Revenue generated (in %) of Moldova in 2000 to that in 2001?
Your answer should be compact. 1.01. What is the ratio of the Revenue generated (in %) of Sweden in 2000 to that in 2001?
Provide a succinct answer. 1.08. What is the ratio of the Revenue generated (in %) of Bhutan in 2000 to that in 2002?
Give a very brief answer. 0.75. What is the ratio of the Revenue generated (in %) of Canada in 2000 to that in 2002?
Offer a very short reply. 0.77. What is the ratio of the Revenue generated (in %) in Moldova in 2000 to that in 2002?
Offer a terse response. 0.89. What is the ratio of the Revenue generated (in %) in Sweden in 2000 to that in 2002?
Provide a succinct answer. 0.96. What is the ratio of the Revenue generated (in %) in Bhutan in 2000 to that in 2003?
Your answer should be compact. 0.55. What is the ratio of the Revenue generated (in %) in Canada in 2000 to that in 2003?
Provide a succinct answer. 0.85. What is the ratio of the Revenue generated (in %) in Moldova in 2000 to that in 2003?
Offer a very short reply. 0.81. What is the ratio of the Revenue generated (in %) of Sweden in 2000 to that in 2003?
Your response must be concise. 1.1. What is the ratio of the Revenue generated (in %) of Bhutan in 2000 to that in 2004?
Offer a very short reply. 0.61. What is the ratio of the Revenue generated (in %) in Canada in 2000 to that in 2004?
Provide a short and direct response. 0.9. What is the ratio of the Revenue generated (in %) of Sweden in 2000 to that in 2004?
Ensure brevity in your answer.  1.06. What is the ratio of the Revenue generated (in %) of Bhutan in 2000 to that in 2005?
Keep it short and to the point. 0.39. What is the ratio of the Revenue generated (in %) of Canada in 2000 to that in 2005?
Offer a terse response. 0.84. What is the ratio of the Revenue generated (in %) of Moldova in 2000 to that in 2005?
Provide a succinct answer. 0.95. What is the ratio of the Revenue generated (in %) in Sweden in 2000 to that in 2005?
Provide a short and direct response. 1.29. What is the ratio of the Revenue generated (in %) in Bhutan in 2001 to that in 2002?
Make the answer very short. 0.9. What is the ratio of the Revenue generated (in %) in Canada in 2001 to that in 2002?
Keep it short and to the point. 0.93. What is the ratio of the Revenue generated (in %) of Moldova in 2001 to that in 2002?
Your answer should be compact. 0.89. What is the ratio of the Revenue generated (in %) of Sweden in 2001 to that in 2002?
Offer a very short reply. 0.89. What is the ratio of the Revenue generated (in %) of Bhutan in 2001 to that in 2003?
Keep it short and to the point. 0.66. What is the ratio of the Revenue generated (in %) in Canada in 2001 to that in 2003?
Your response must be concise. 1.03. What is the ratio of the Revenue generated (in %) of Moldova in 2001 to that in 2003?
Offer a terse response. 0.81. What is the ratio of the Revenue generated (in %) of Sweden in 2001 to that in 2003?
Your answer should be compact. 1.02. What is the ratio of the Revenue generated (in %) in Bhutan in 2001 to that in 2004?
Provide a succinct answer. 0.74. What is the ratio of the Revenue generated (in %) of Canada in 2001 to that in 2004?
Offer a terse response. 1.1. What is the ratio of the Revenue generated (in %) of Moldova in 2001 to that in 2004?
Provide a short and direct response. 0.99. What is the ratio of the Revenue generated (in %) in Sweden in 2001 to that in 2004?
Provide a short and direct response. 0.99. What is the ratio of the Revenue generated (in %) of Bhutan in 2001 to that in 2005?
Offer a very short reply. 0.48. What is the ratio of the Revenue generated (in %) of Canada in 2001 to that in 2005?
Provide a short and direct response. 1.02. What is the ratio of the Revenue generated (in %) in Moldova in 2001 to that in 2005?
Your response must be concise. 0.95. What is the ratio of the Revenue generated (in %) of Sweden in 2001 to that in 2005?
Ensure brevity in your answer.  1.2. What is the ratio of the Revenue generated (in %) of Bhutan in 2002 to that in 2003?
Keep it short and to the point. 0.74. What is the ratio of the Revenue generated (in %) of Canada in 2002 to that in 2003?
Offer a terse response. 1.11. What is the ratio of the Revenue generated (in %) in Moldova in 2002 to that in 2003?
Offer a terse response. 0.91. What is the ratio of the Revenue generated (in %) in Sweden in 2002 to that in 2003?
Offer a very short reply. 1.15. What is the ratio of the Revenue generated (in %) in Bhutan in 2002 to that in 2004?
Offer a very short reply. 0.82. What is the ratio of the Revenue generated (in %) in Canada in 2002 to that in 2004?
Your answer should be compact. 1.18. What is the ratio of the Revenue generated (in %) in Moldova in 2002 to that in 2004?
Make the answer very short. 1.11. What is the ratio of the Revenue generated (in %) in Sweden in 2002 to that in 2004?
Ensure brevity in your answer.  1.11. What is the ratio of the Revenue generated (in %) of Bhutan in 2002 to that in 2005?
Provide a succinct answer. 0.53. What is the ratio of the Revenue generated (in %) in Canada in 2002 to that in 2005?
Provide a short and direct response. 1.1. What is the ratio of the Revenue generated (in %) in Moldova in 2002 to that in 2005?
Keep it short and to the point. 1.07. What is the ratio of the Revenue generated (in %) of Sweden in 2002 to that in 2005?
Keep it short and to the point. 1.35. What is the ratio of the Revenue generated (in %) in Bhutan in 2003 to that in 2004?
Keep it short and to the point. 1.11. What is the ratio of the Revenue generated (in %) of Canada in 2003 to that in 2004?
Your answer should be compact. 1.07. What is the ratio of the Revenue generated (in %) in Moldova in 2003 to that in 2004?
Your answer should be compact. 1.22. What is the ratio of the Revenue generated (in %) of Bhutan in 2003 to that in 2005?
Offer a very short reply. 0.71. What is the ratio of the Revenue generated (in %) in Moldova in 2003 to that in 2005?
Keep it short and to the point. 1.17. What is the ratio of the Revenue generated (in %) of Sweden in 2003 to that in 2005?
Ensure brevity in your answer.  1.17. What is the ratio of the Revenue generated (in %) of Bhutan in 2004 to that in 2005?
Keep it short and to the point. 0.64. What is the ratio of the Revenue generated (in %) in Canada in 2004 to that in 2005?
Make the answer very short. 0.93. What is the ratio of the Revenue generated (in %) in Sweden in 2004 to that in 2005?
Your response must be concise. 1.21. What is the difference between the highest and the second highest Revenue generated (in %) in Bhutan?
Give a very brief answer. 0.66. What is the difference between the highest and the second highest Revenue generated (in %) of Canada?
Offer a terse response. 0. What is the difference between the highest and the second highest Revenue generated (in %) in Moldova?
Ensure brevity in your answer.  0.78. What is the difference between the highest and the second highest Revenue generated (in %) of Sweden?
Make the answer very short. 0.01. What is the difference between the highest and the lowest Revenue generated (in %) in Bhutan?
Provide a short and direct response. 1.41. What is the difference between the highest and the lowest Revenue generated (in %) of Canada?
Provide a short and direct response. 0.32. What is the difference between the highest and the lowest Revenue generated (in %) in Moldova?
Provide a short and direct response. 3.46. What is the difference between the highest and the lowest Revenue generated (in %) in Sweden?
Provide a succinct answer. 0.04. 